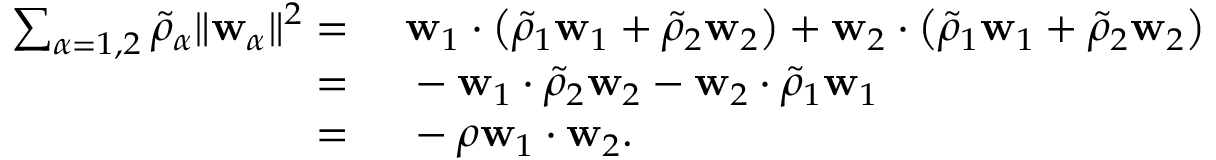<formula> <loc_0><loc_0><loc_500><loc_500>\begin{array} { r l } { \sum _ { \alpha = 1 , 2 } \tilde { \rho } _ { \alpha } \| w _ { \alpha } \| ^ { 2 } = } & w _ { 1 } \cdot \left ( \tilde { \rho } _ { 1 } w _ { 1 } + \tilde { \rho } _ { 2 } w _ { 2 } \right ) + w _ { 2 } \cdot \left ( \tilde { \rho } _ { 1 } w _ { 1 } + \tilde { \rho } _ { 2 } w _ { 2 } \right ) } \\ { = } & - w _ { 1 } \cdot \tilde { \rho } _ { 2 } w _ { 2 } - w _ { 2 } \cdot \tilde { \rho } _ { 1 } w _ { 1 } } \\ { = } & - \rho w _ { 1 } \cdot w _ { 2 } . } \end{array}</formula> 